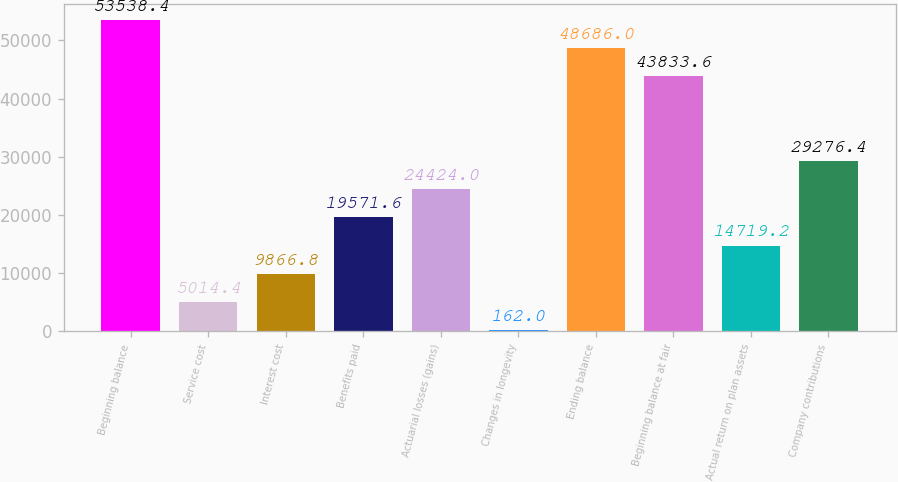<chart> <loc_0><loc_0><loc_500><loc_500><bar_chart><fcel>Beginning balance<fcel>Service cost<fcel>Interest cost<fcel>Benefits paid<fcel>Actuarial losses (gains)<fcel>Changes in longevity<fcel>Ending balance<fcel>Beginning balance at fair<fcel>Actual return on plan assets<fcel>Company contributions<nl><fcel>53538.4<fcel>5014.4<fcel>9866.8<fcel>19571.6<fcel>24424<fcel>162<fcel>48686<fcel>43833.6<fcel>14719.2<fcel>29276.4<nl></chart> 